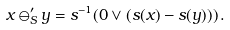Convert formula to latex. <formula><loc_0><loc_0><loc_500><loc_500>x \ominus ^ { \prime } _ { S } y = s ^ { - 1 } ( 0 \vee ( s ( x ) - s ( y ) ) ) \, .</formula> 